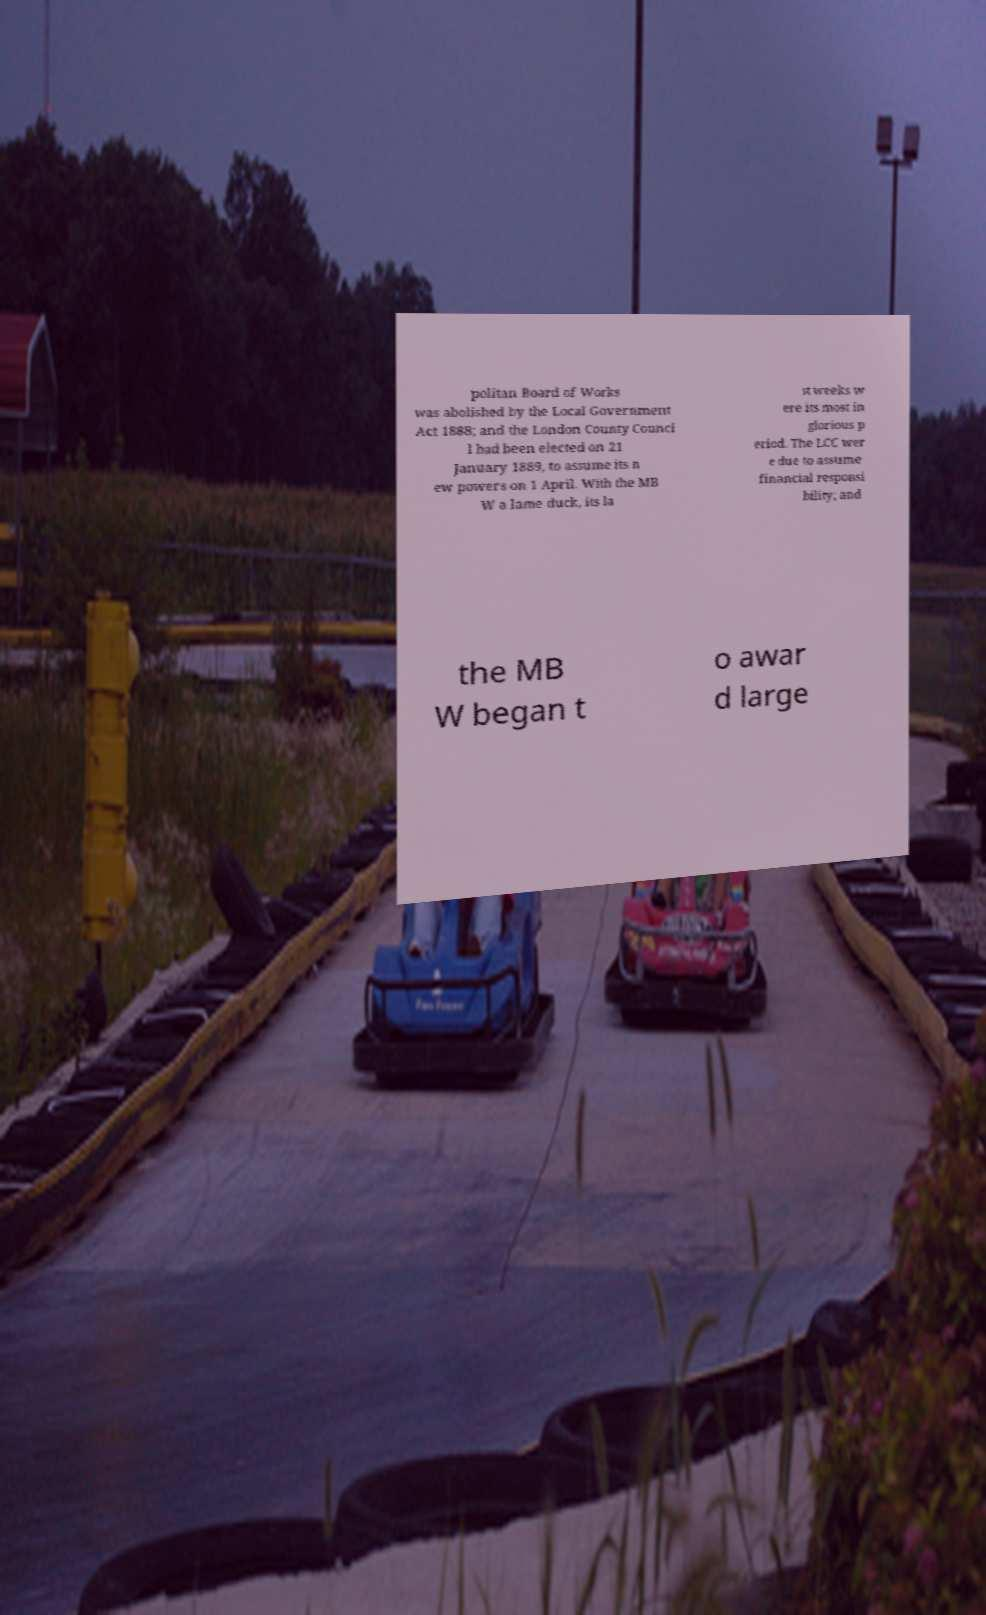Could you assist in decoding the text presented in this image and type it out clearly? politan Board of Works was abolished by the Local Government Act 1888; and the London County Counci l had been elected on 21 January 1889, to assume its n ew powers on 1 April. With the MB W a lame duck, its la st weeks w ere its most in glorious p eriod. The LCC wer e due to assume financial responsi bility; and the MB W began t o awar d large 